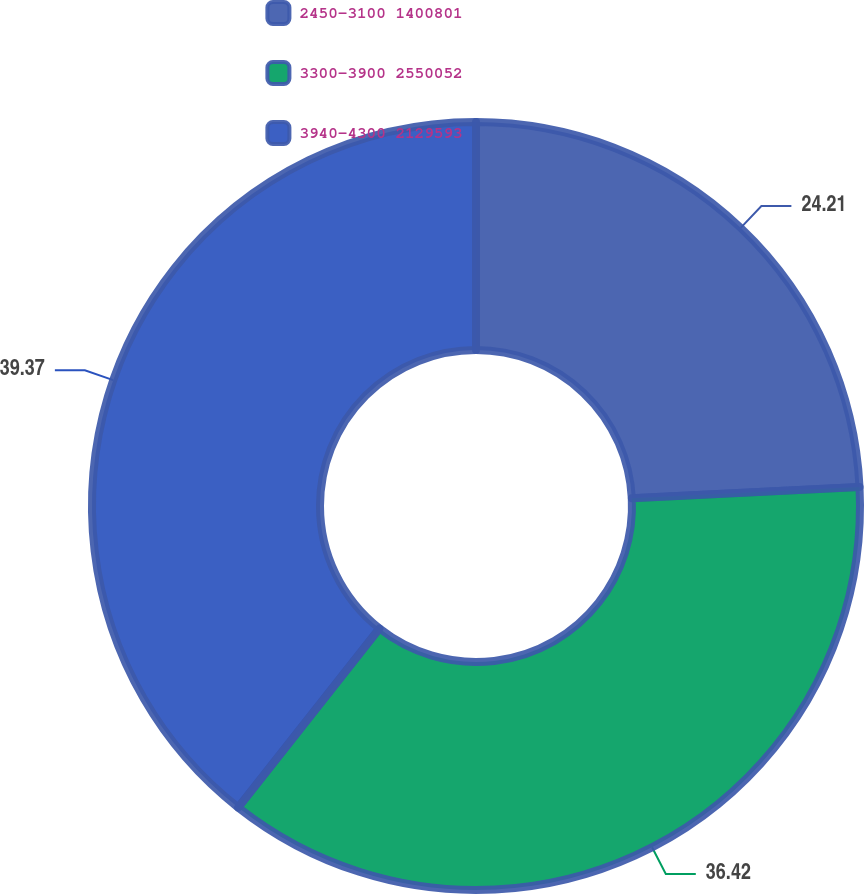<chart> <loc_0><loc_0><loc_500><loc_500><pie_chart><fcel>2450-3100 1400801<fcel>3300-3900 2550052<fcel>3940-4300 2129593<nl><fcel>24.21%<fcel>36.42%<fcel>39.37%<nl></chart> 